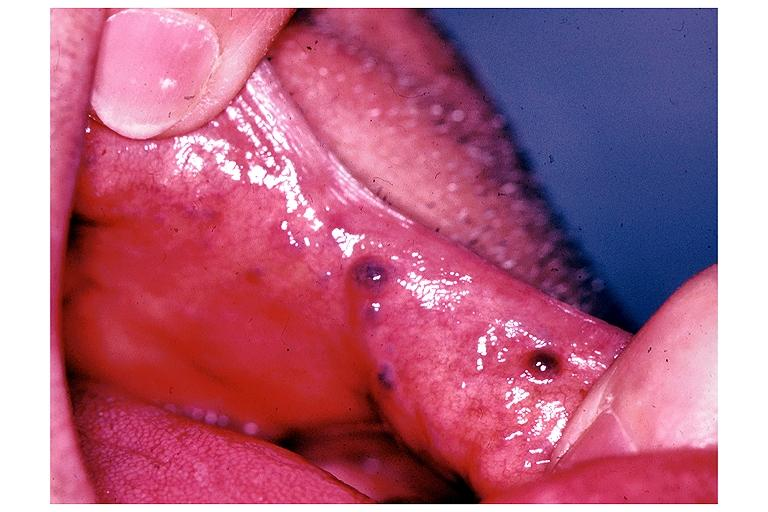s brain, cryptococcal meningitis, pas present?
Answer the question using a single word or phrase. No 